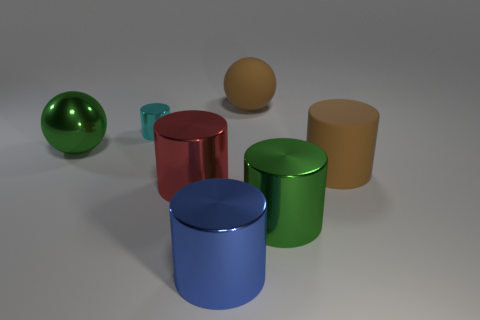What number of other things are the same shape as the big red shiny thing?
Offer a terse response. 4. Is the number of big metallic cylinders that are in front of the large red metallic object the same as the number of tiny cyan cylinders that are in front of the large brown cylinder?
Provide a succinct answer. No. Are any large cyan rubber cubes visible?
Your answer should be very brief. No. What size is the brown object right of the sphere behind the green metal thing left of the large green shiny cylinder?
Your answer should be very brief. Large. What is the shape of the red metal thing that is the same size as the green cylinder?
Provide a short and direct response. Cylinder. How many things are either metal cylinders that are behind the blue cylinder or small gray shiny cylinders?
Your answer should be very brief. 3. Is there a large cylinder that is in front of the big rubber thing in front of the large green thing that is to the left of the green cylinder?
Give a very brief answer. Yes. How many things are there?
Your answer should be compact. 7. What number of things are either objects that are right of the tiny thing or big shiny cylinders on the right side of the red cylinder?
Give a very brief answer. 5. There is a sphere in front of the rubber ball; does it have the same size as the rubber sphere?
Give a very brief answer. Yes. 